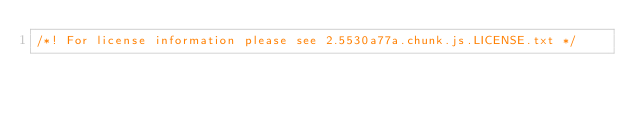<code> <loc_0><loc_0><loc_500><loc_500><_JavaScript_>/*! For license information please see 2.5530a77a.chunk.js.LICENSE.txt */</code> 